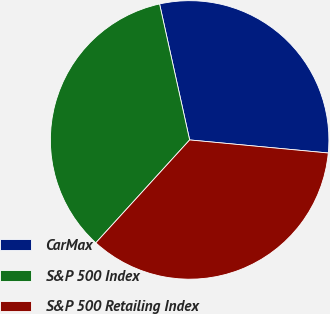<chart> <loc_0><loc_0><loc_500><loc_500><pie_chart><fcel>CarMax<fcel>S&P 500 Index<fcel>S&P 500 Retailing Index<nl><fcel>29.96%<fcel>34.77%<fcel>35.27%<nl></chart> 